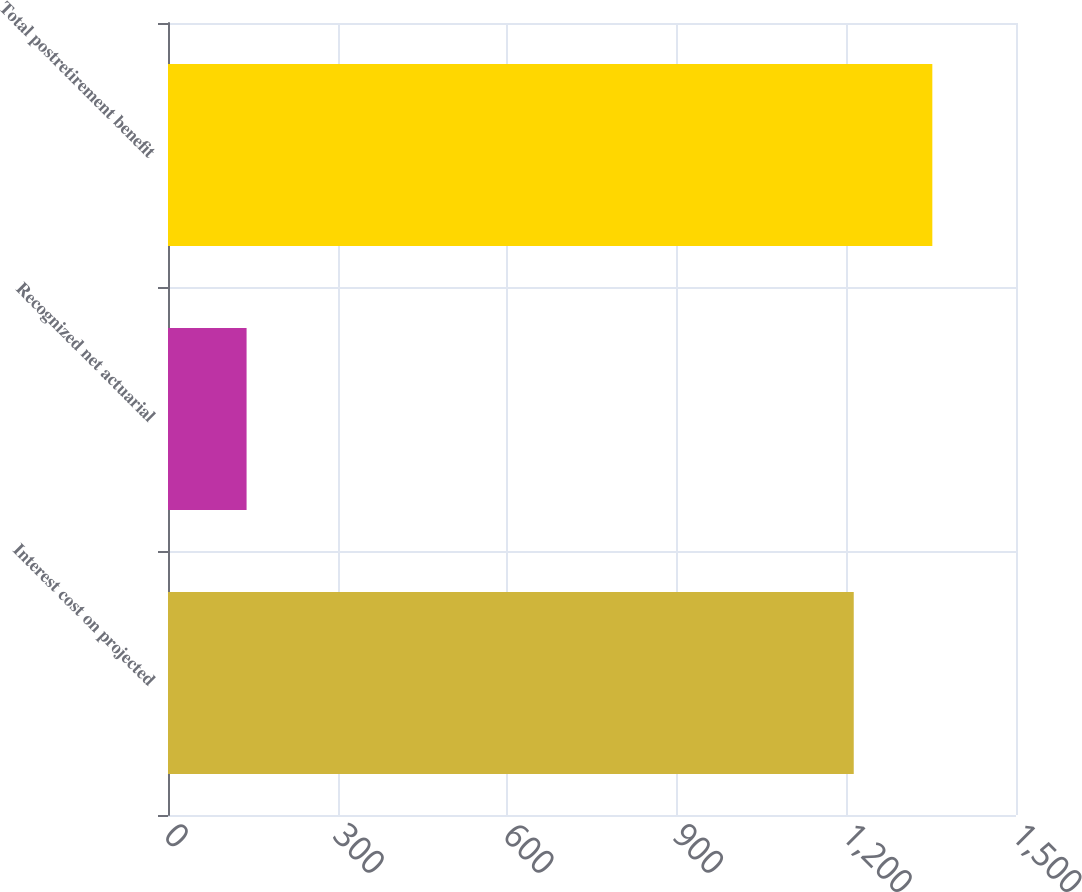Convert chart to OTSL. <chart><loc_0><loc_0><loc_500><loc_500><bar_chart><fcel>Interest cost on projected<fcel>Recognized net actuarial<fcel>Total postretirement benefit<nl><fcel>1213<fcel>139<fcel>1352<nl></chart> 